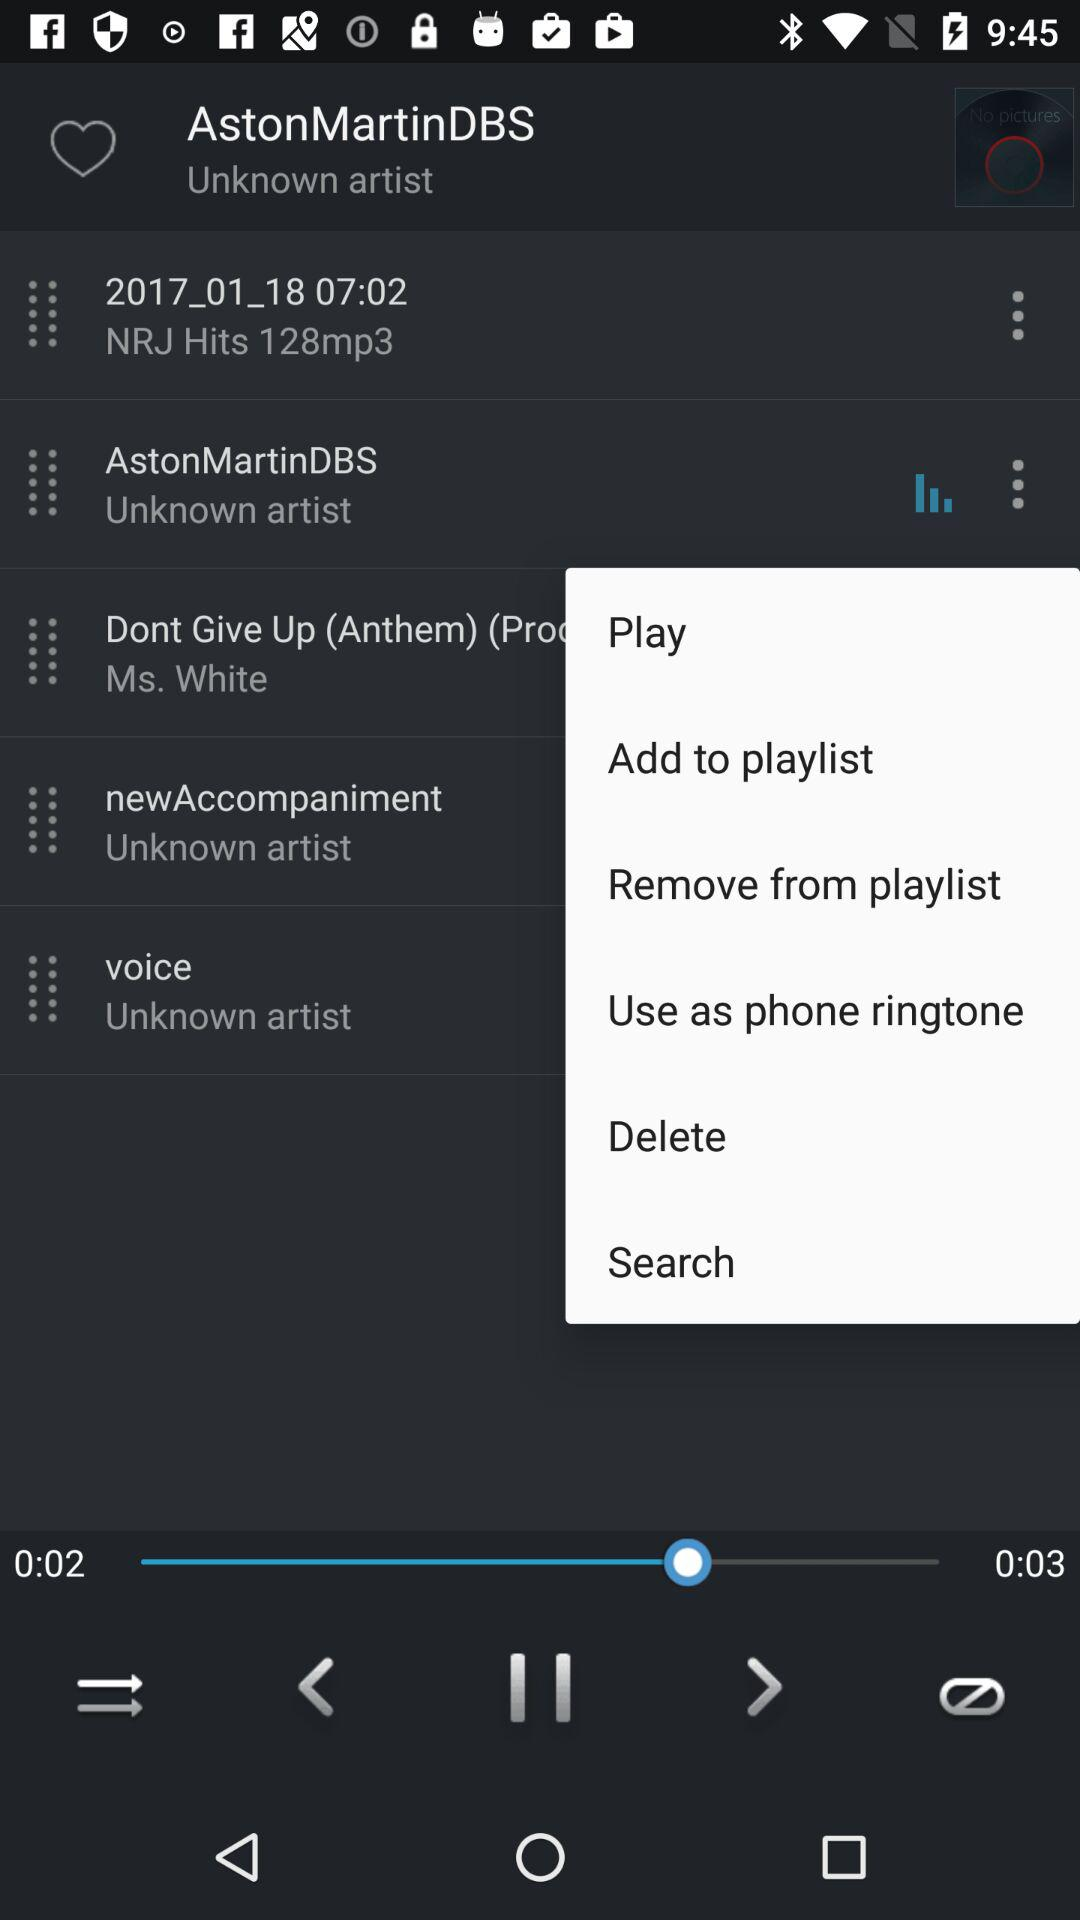How long is the currently playing audio? The currently playing audio is 3 seconds long. 